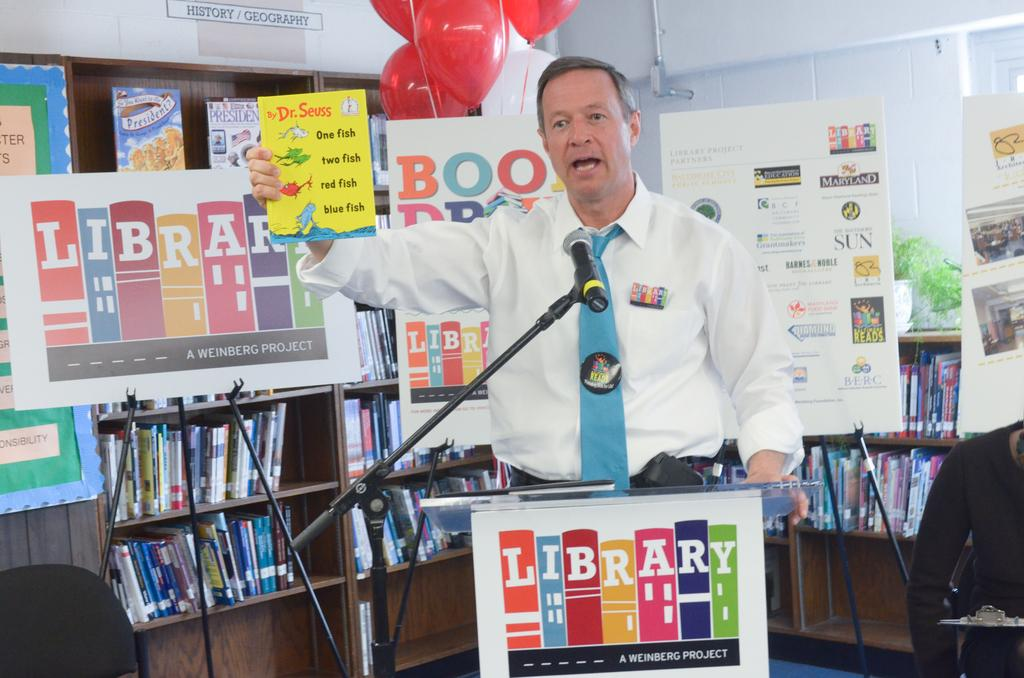<image>
Summarize the visual content of the image. Libraries are sure to have a Dr. Seuss book or on hand at al times. 